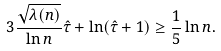<formula> <loc_0><loc_0><loc_500><loc_500>3 \frac { \sqrt { \lambda ( n ) } } { \ln n } \hat { \tau } + \ln ( \hat { \tau } + 1 ) \geq \frac { 1 } { 5 } \ln n .</formula> 